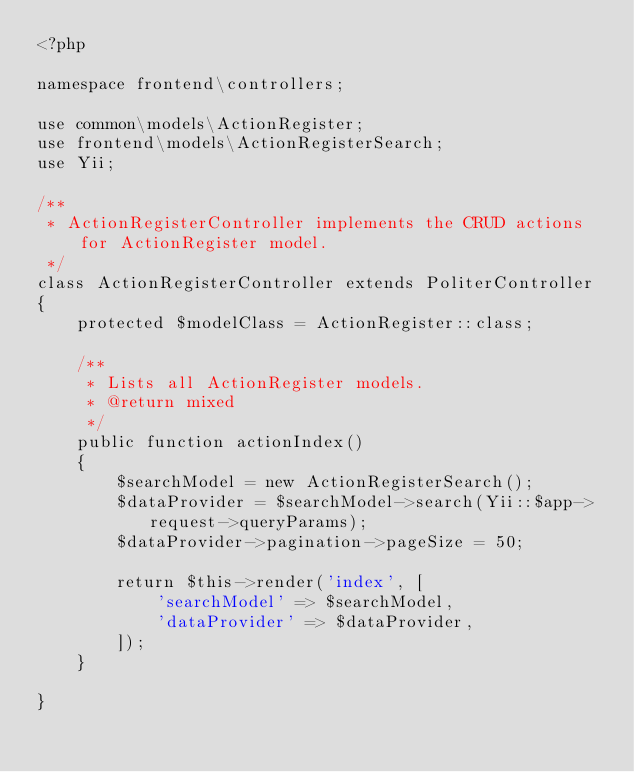Convert code to text. <code><loc_0><loc_0><loc_500><loc_500><_PHP_><?php

namespace frontend\controllers;

use common\models\ActionRegister;
use frontend\models\ActionRegisterSearch;
use Yii;

/**
 * ActionRegisterController implements the CRUD actions for ActionRegister model.
 */
class ActionRegisterController extends PoliterController
{
    protected $modelClass = ActionRegister::class;

    /**
     * Lists all ActionRegister models.
     * @return mixed
     */
    public function actionIndex()
    {
        $searchModel = new ActionRegisterSearch();
        $dataProvider = $searchModel->search(Yii::$app->request->queryParams);
        $dataProvider->pagination->pageSize = 50;

        return $this->render('index', [
            'searchModel' => $searchModel,
            'dataProvider' => $dataProvider,
        ]);
    }

}
</code> 